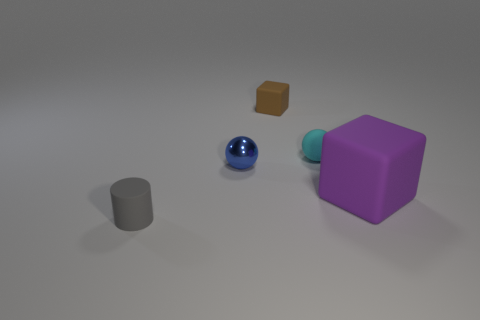Are there more balls right of the tiny cyan matte ball than blue objects that are on the right side of the shiny object?
Provide a short and direct response. No. What color is the other big object that is the same shape as the brown object?
Offer a very short reply. Purple. Are there any other things that are the same shape as the tiny cyan thing?
Provide a succinct answer. Yes. There is a large purple thing; is it the same shape as the matte thing that is behind the small cyan rubber ball?
Ensure brevity in your answer.  Yes. What number of other objects are there of the same material as the blue sphere?
Provide a short and direct response. 0. There is a block that is behind the cyan matte ball; what is it made of?
Offer a terse response. Rubber. The cylinder that is the same size as the blue ball is what color?
Your response must be concise. Gray. What number of large things are cyan metallic blocks or blue metal balls?
Provide a short and direct response. 0. Are there an equal number of large purple matte things left of the blue thing and big rubber things that are in front of the brown thing?
Make the answer very short. No. How many other matte blocks are the same size as the purple block?
Your response must be concise. 0. 